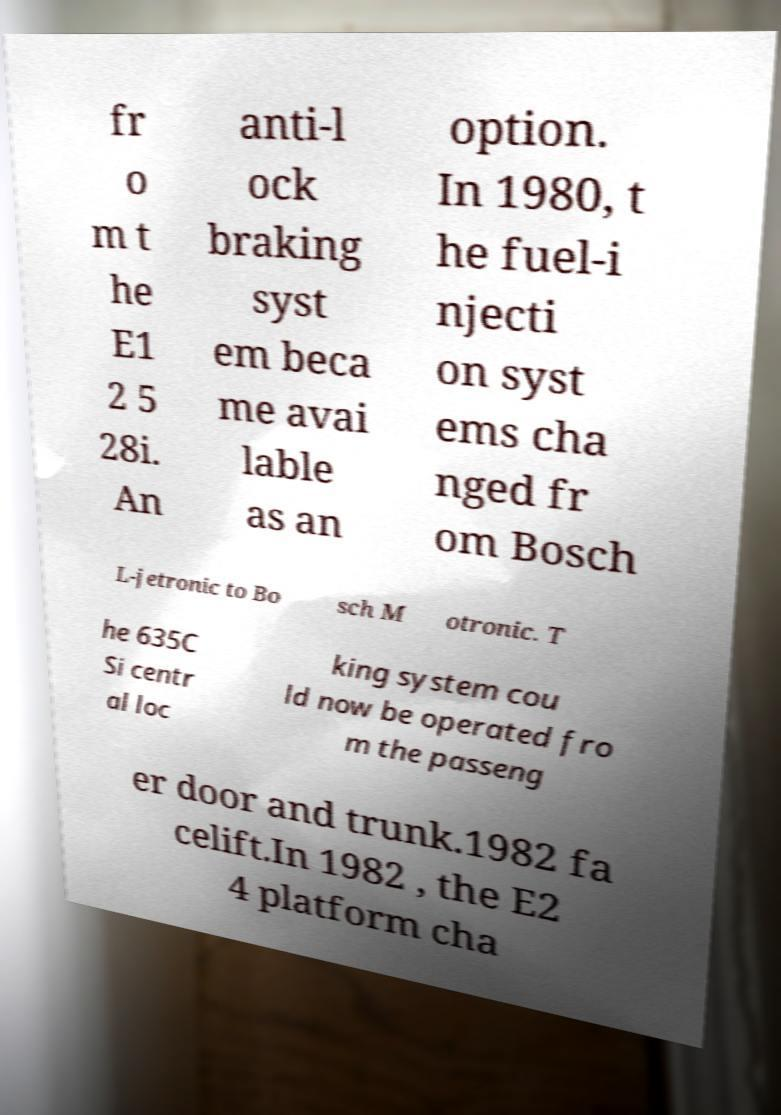There's text embedded in this image that I need extracted. Can you transcribe it verbatim? fr o m t he E1 2 5 28i. An anti-l ock braking syst em beca me avai lable as an option. In 1980, t he fuel-i njecti on syst ems cha nged fr om Bosch L-jetronic to Bo sch M otronic. T he 635C Si centr al loc king system cou ld now be operated fro m the passeng er door and trunk.1982 fa celift.In 1982 , the E2 4 platform cha 